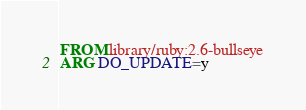<code> <loc_0><loc_0><loc_500><loc_500><_Dockerfile_>FROM library/ruby:2.6-bullseye
ARG DO_UPDATE=y</code> 